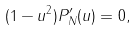<formula> <loc_0><loc_0><loc_500><loc_500>( 1 - u ^ { 2 } ) P _ { N } ^ { \prime } ( u ) = 0 ,</formula> 